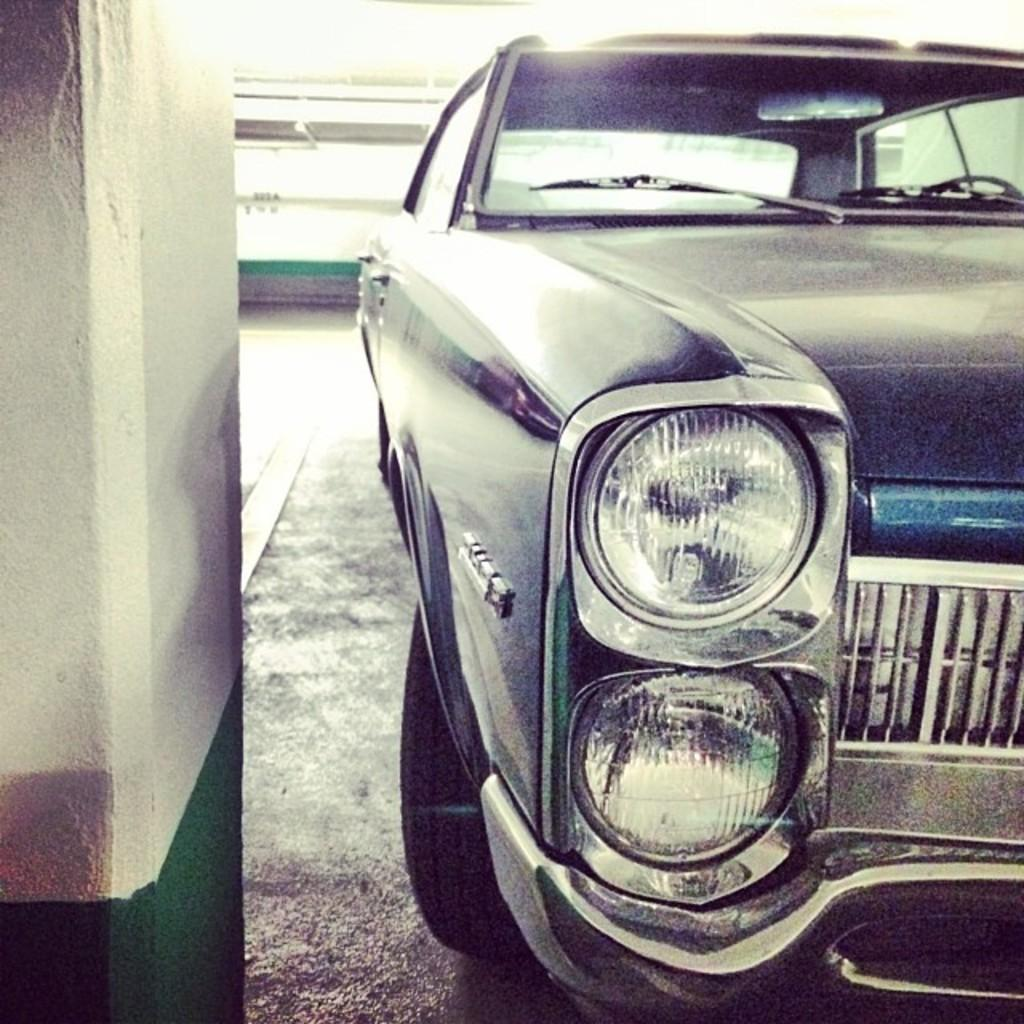What is the main subject of the image? There is a car in the image. Can you describe the car's position in the image? The car is placed on a surface. What can be seen on the left side of the image? There is a pillar on the left side of the image. What is visible on the backside of the image? There is a wall visible on the backside of the image. What type of stone is used to make the eggnog in the image? There is no eggnog present in the image, and therefore no stone or any other ingredient related to eggnog can be observed. 